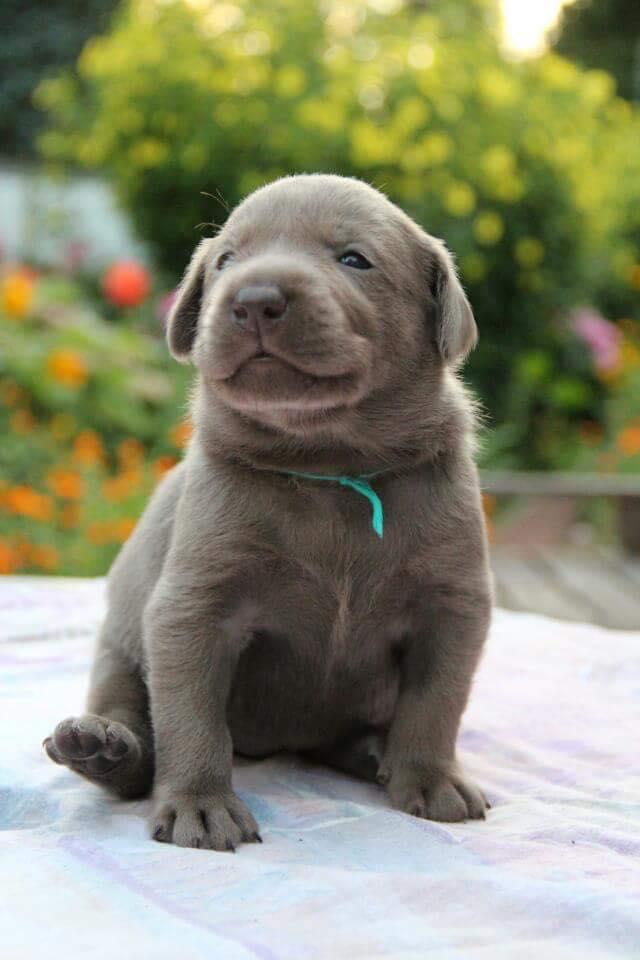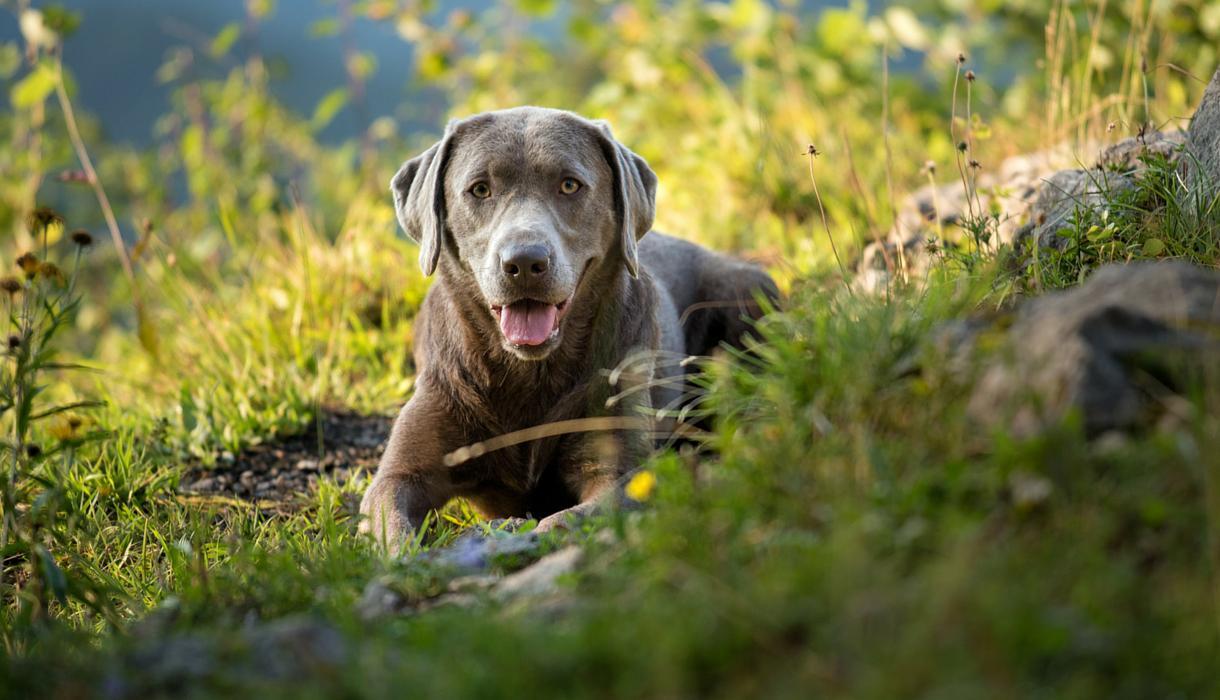The first image is the image on the left, the second image is the image on the right. Evaluate the accuracy of this statement regarding the images: "An image shows a blue-eyed gray dog wearing a red collar.". Is it true? Answer yes or no. No. The first image is the image on the left, the second image is the image on the right. For the images shown, is this caption "Someone is holding one of the dogs." true? Answer yes or no. No. 